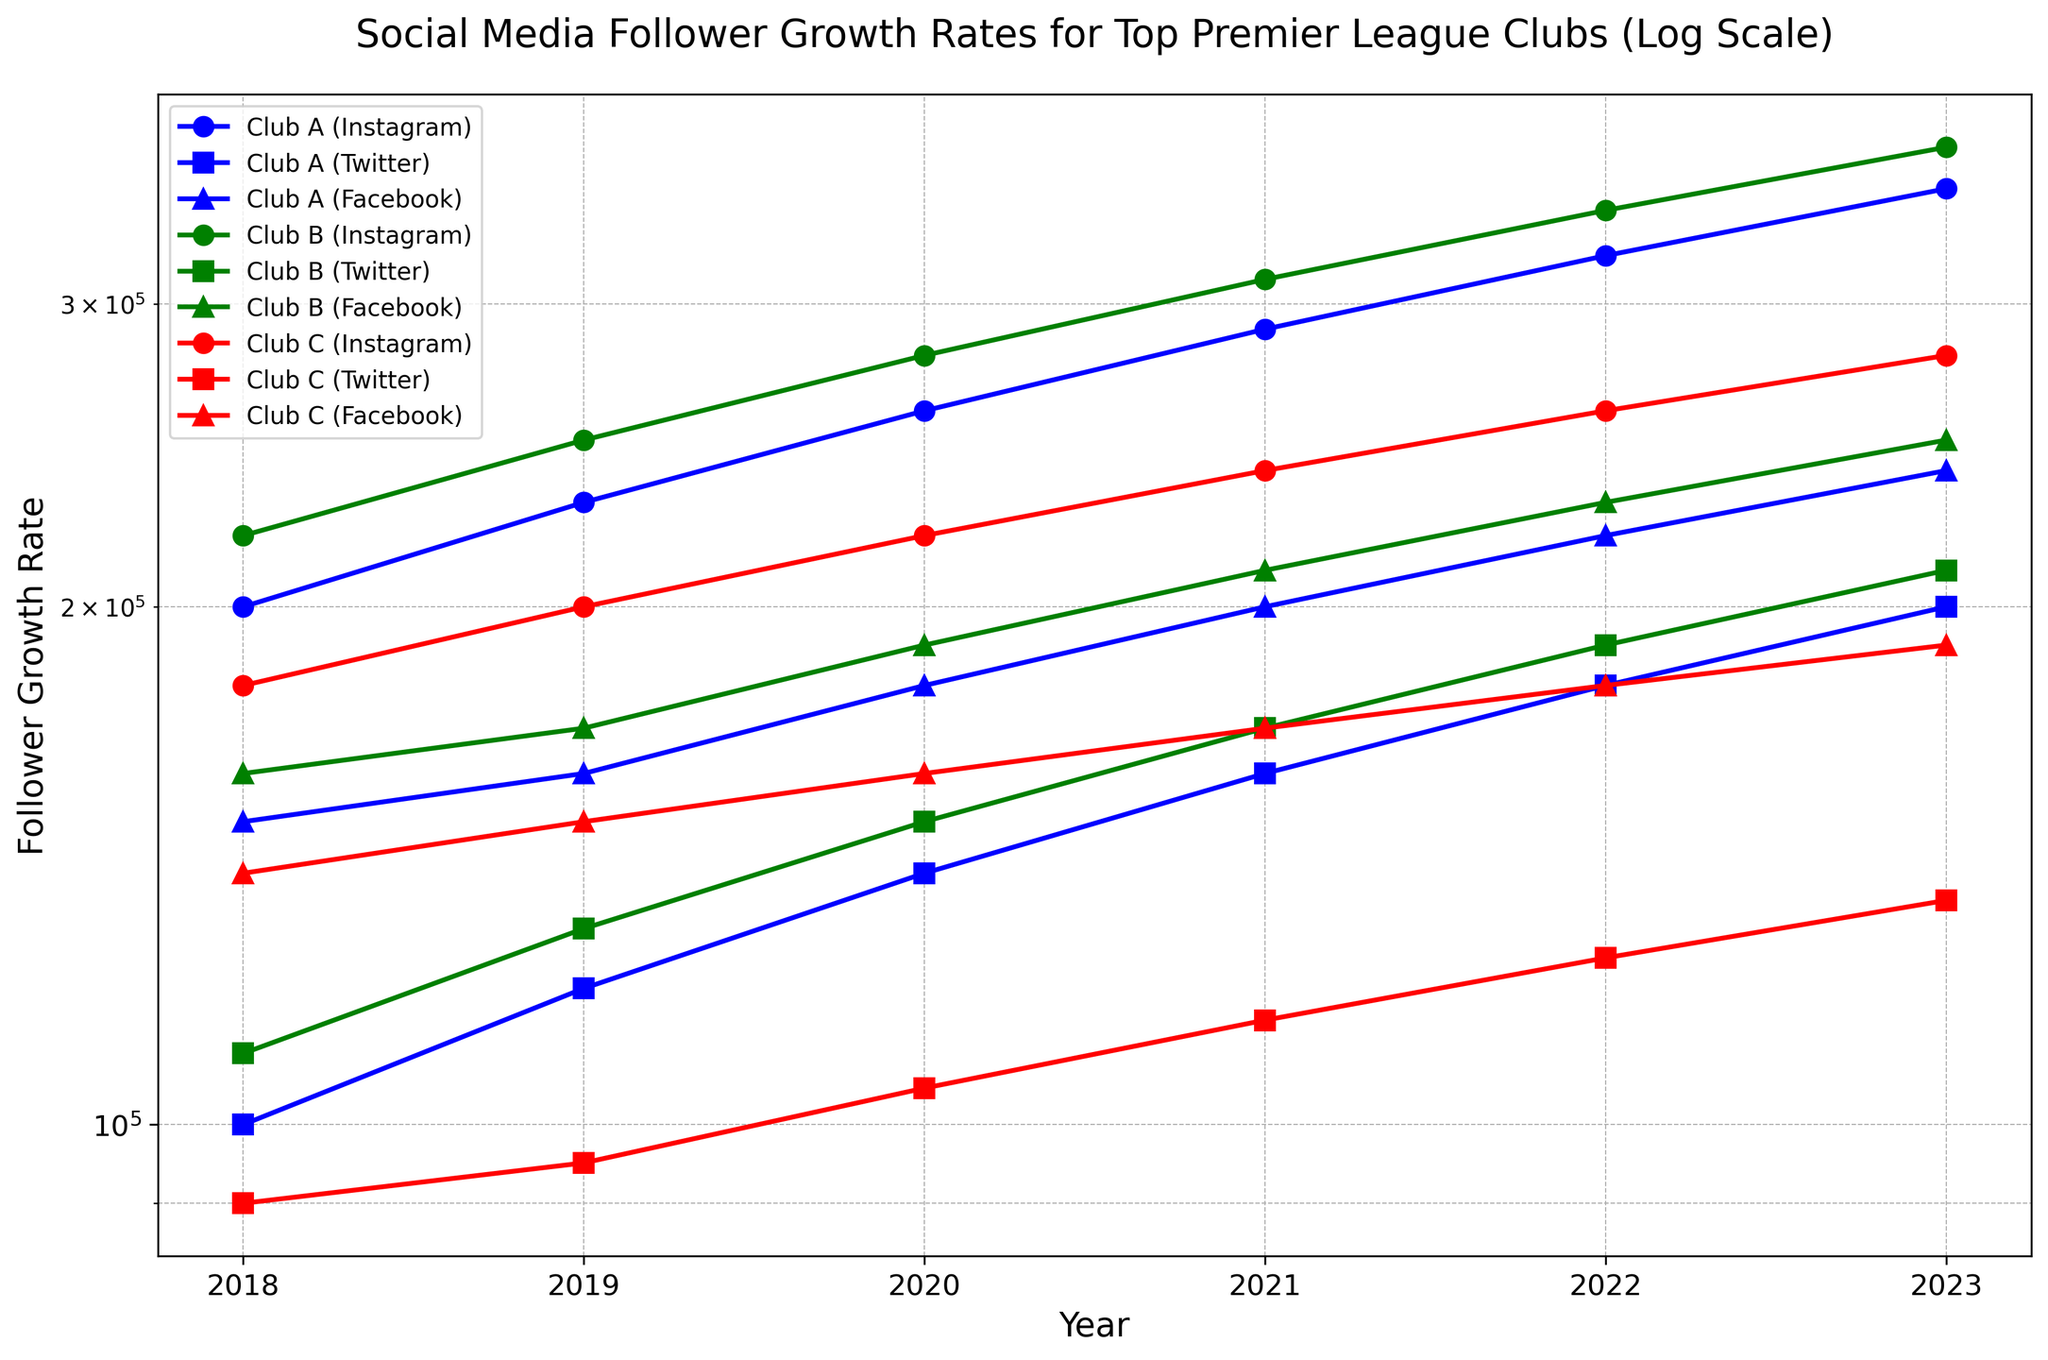What's the percentage increase in Club A's Instagram follower growth rate from 2018 to 2023? First, find the follower growth rate for Club A on Instagram in 2018 (200,000) and in 2023 (350,000). The percentage increase formula is [(new value - old value) / old value] * 100. So, [(350,000 - 200,000) / 200,000] * 100 = (150,000 / 200,000) * 100 = 75%
Answer: 75% Which club had the highest follower growth rate on Twitter in 2021? Look at the Twitter data points for all clubs in 2021. Club A has 160,000, Club B has 170,000, and Club C has 115,000. Club B has the highest at 170,000
Answer: Club B Did Club C's Instagram follower growth rate double between any two consecutive years? Check the Instagram growth rates for Club C over the years: 2018 (180,000), 2019 (200,000), 2020 (220,000), 2021 (240,000), 2022 (260,000), and 2023 (280,000). None of these values double from one year to the next
Answer: No Between 2020 and 2023, which platform showed the greatest increase in follower growth rate for Club B? Calculate the differences in growth rates for Instagram (370,000 - 280,000 = 90,000), Twitter (210,000 - 150,000 = 60,000), and Facebook (250,000 - 190,000 = 60,000). Instagram shows the greatest increase of 90,000
Answer: Instagram Has any club experienced a decrease in their follower growth rate on Facebook between any consecutive years? Look at the Facebook data points for all clubs. None of the clubs show a decrease; they all either stay the same or increase gradually
Answer: No From 2018 to 2023, which club has shown the most consistent growth on Twitter? Assess the growth patterns on Twitter for each club across the years. Club A: (100,000, 120,000, 140,000, 160,000, 180,000, 200,000); Club B: (110,000, 130,000, 150,000, 170,000, 190,000, 210,000); Club C: (90,000, 95,000, 105,000, 115,000, 125,000, 135,000). Club C shows the most linear and steady increase
Answer: Club C In 2023, which platform had the lowest follower growth rate for Club C? Look at the data for Club C in 2023: Instagram (280,000), Twitter (135,000), and Facebook (190,000). Twitter has the lowest rate with 135,000
Answer: Twitter Between 2018 and 2023, which club experienced the highest overall growth in Instagram followers? Calculate the difference in Instagram follower growth for each club from 2018 to 2023: Club A (350,000 - 200,000 = 150,000), Club B (370,000 - 220,000 = 150,000), and Club C (280,000 - 180,000 = 100,000). Club A and Club B both have the highest overall growth with an increase of 150,000
Answer: Club A and Club B 